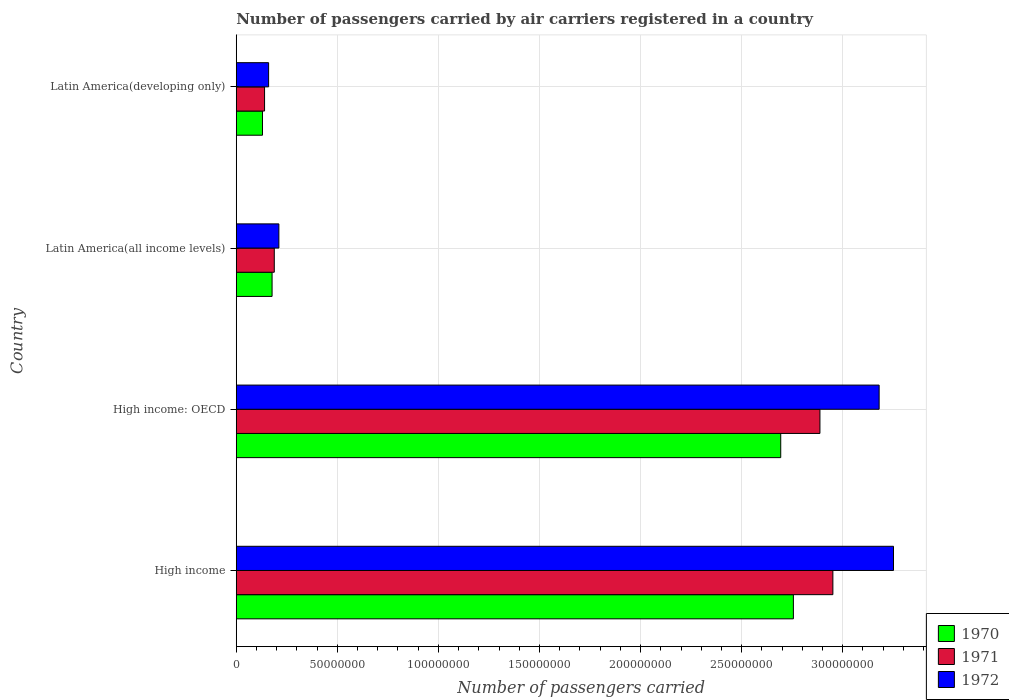How many groups of bars are there?
Provide a succinct answer. 4. Are the number of bars per tick equal to the number of legend labels?
Offer a very short reply. Yes. Are the number of bars on each tick of the Y-axis equal?
Offer a very short reply. Yes. How many bars are there on the 4th tick from the top?
Your response must be concise. 3. How many bars are there on the 2nd tick from the bottom?
Provide a short and direct response. 3. What is the label of the 4th group of bars from the top?
Offer a terse response. High income. What is the number of passengers carried by air carriers in 1970 in Latin America(developing only)?
Offer a terse response. 1.30e+07. Across all countries, what is the maximum number of passengers carried by air carriers in 1970?
Provide a short and direct response. 2.76e+08. Across all countries, what is the minimum number of passengers carried by air carriers in 1970?
Give a very brief answer. 1.30e+07. In which country was the number of passengers carried by air carriers in 1970 maximum?
Provide a short and direct response. High income. In which country was the number of passengers carried by air carriers in 1971 minimum?
Provide a succinct answer. Latin America(developing only). What is the total number of passengers carried by air carriers in 1972 in the graph?
Offer a very short reply. 6.80e+08. What is the difference between the number of passengers carried by air carriers in 1971 in Latin America(all income levels) and that in Latin America(developing only)?
Your response must be concise. 4.81e+06. What is the difference between the number of passengers carried by air carriers in 1972 in High income: OECD and the number of passengers carried by air carriers in 1971 in High income?
Give a very brief answer. 2.29e+07. What is the average number of passengers carried by air carriers in 1970 per country?
Offer a very short reply. 1.44e+08. What is the difference between the number of passengers carried by air carriers in 1971 and number of passengers carried by air carriers in 1970 in Latin America(all income levels)?
Ensure brevity in your answer.  1.09e+06. What is the ratio of the number of passengers carried by air carriers in 1972 in High income: OECD to that in Latin America(developing only)?
Make the answer very short. 19.87. Is the difference between the number of passengers carried by air carriers in 1971 in Latin America(all income levels) and Latin America(developing only) greater than the difference between the number of passengers carried by air carriers in 1970 in Latin America(all income levels) and Latin America(developing only)?
Provide a succinct answer. Yes. What is the difference between the highest and the second highest number of passengers carried by air carriers in 1970?
Offer a very short reply. 6.26e+06. What is the difference between the highest and the lowest number of passengers carried by air carriers in 1970?
Ensure brevity in your answer.  2.63e+08. What does the 3rd bar from the top in Latin America(all income levels) represents?
Your answer should be very brief. 1970. Is it the case that in every country, the sum of the number of passengers carried by air carriers in 1971 and number of passengers carried by air carriers in 1972 is greater than the number of passengers carried by air carriers in 1970?
Keep it short and to the point. Yes. How many bars are there?
Offer a very short reply. 12. How many legend labels are there?
Offer a terse response. 3. How are the legend labels stacked?
Your answer should be very brief. Vertical. What is the title of the graph?
Give a very brief answer. Number of passengers carried by air carriers registered in a country. Does "1995" appear as one of the legend labels in the graph?
Ensure brevity in your answer.  No. What is the label or title of the X-axis?
Offer a very short reply. Number of passengers carried. What is the Number of passengers carried of 1970 in High income?
Give a very brief answer. 2.76e+08. What is the Number of passengers carried in 1971 in High income?
Provide a succinct answer. 2.95e+08. What is the Number of passengers carried in 1972 in High income?
Offer a very short reply. 3.25e+08. What is the Number of passengers carried in 1970 in High income: OECD?
Your answer should be very brief. 2.69e+08. What is the Number of passengers carried of 1971 in High income: OECD?
Provide a short and direct response. 2.89e+08. What is the Number of passengers carried of 1972 in High income: OECD?
Your response must be concise. 3.18e+08. What is the Number of passengers carried of 1970 in Latin America(all income levels)?
Provide a succinct answer. 1.77e+07. What is the Number of passengers carried of 1971 in Latin America(all income levels)?
Make the answer very short. 1.88e+07. What is the Number of passengers carried in 1972 in Latin America(all income levels)?
Offer a very short reply. 2.11e+07. What is the Number of passengers carried in 1970 in Latin America(developing only)?
Make the answer very short. 1.30e+07. What is the Number of passengers carried of 1971 in Latin America(developing only)?
Offer a very short reply. 1.40e+07. What is the Number of passengers carried in 1972 in Latin America(developing only)?
Your response must be concise. 1.60e+07. Across all countries, what is the maximum Number of passengers carried in 1970?
Provide a succinct answer. 2.76e+08. Across all countries, what is the maximum Number of passengers carried in 1971?
Give a very brief answer. 2.95e+08. Across all countries, what is the maximum Number of passengers carried of 1972?
Your answer should be compact. 3.25e+08. Across all countries, what is the minimum Number of passengers carried in 1970?
Provide a short and direct response. 1.30e+07. Across all countries, what is the minimum Number of passengers carried in 1971?
Give a very brief answer. 1.40e+07. Across all countries, what is the minimum Number of passengers carried in 1972?
Provide a succinct answer. 1.60e+07. What is the total Number of passengers carried in 1970 in the graph?
Your answer should be very brief. 5.76e+08. What is the total Number of passengers carried of 1971 in the graph?
Your response must be concise. 6.17e+08. What is the total Number of passengers carried in 1972 in the graph?
Offer a very short reply. 6.80e+08. What is the difference between the Number of passengers carried in 1970 in High income and that in High income: OECD?
Provide a short and direct response. 6.26e+06. What is the difference between the Number of passengers carried in 1971 in High income and that in High income: OECD?
Offer a very short reply. 6.40e+06. What is the difference between the Number of passengers carried of 1972 in High income and that in High income: OECD?
Your answer should be compact. 7.11e+06. What is the difference between the Number of passengers carried of 1970 in High income and that in Latin America(all income levels)?
Provide a short and direct response. 2.58e+08. What is the difference between the Number of passengers carried of 1971 in High income and that in Latin America(all income levels)?
Your answer should be very brief. 2.76e+08. What is the difference between the Number of passengers carried of 1972 in High income and that in Latin America(all income levels)?
Offer a very short reply. 3.04e+08. What is the difference between the Number of passengers carried in 1970 in High income and that in Latin America(developing only)?
Your answer should be very brief. 2.63e+08. What is the difference between the Number of passengers carried of 1971 in High income and that in Latin America(developing only)?
Offer a terse response. 2.81e+08. What is the difference between the Number of passengers carried of 1972 in High income and that in Latin America(developing only)?
Make the answer very short. 3.09e+08. What is the difference between the Number of passengers carried of 1970 in High income: OECD and that in Latin America(all income levels)?
Your answer should be compact. 2.52e+08. What is the difference between the Number of passengers carried in 1971 in High income: OECD and that in Latin America(all income levels)?
Provide a succinct answer. 2.70e+08. What is the difference between the Number of passengers carried in 1972 in High income: OECD and that in Latin America(all income levels)?
Provide a short and direct response. 2.97e+08. What is the difference between the Number of passengers carried of 1970 in High income: OECD and that in Latin America(developing only)?
Give a very brief answer. 2.56e+08. What is the difference between the Number of passengers carried in 1971 in High income: OECD and that in Latin America(developing only)?
Your response must be concise. 2.75e+08. What is the difference between the Number of passengers carried in 1972 in High income: OECD and that in Latin America(developing only)?
Your answer should be very brief. 3.02e+08. What is the difference between the Number of passengers carried in 1970 in Latin America(all income levels) and that in Latin America(developing only)?
Keep it short and to the point. 4.74e+06. What is the difference between the Number of passengers carried of 1971 in Latin America(all income levels) and that in Latin America(developing only)?
Your answer should be compact. 4.81e+06. What is the difference between the Number of passengers carried of 1972 in Latin America(all income levels) and that in Latin America(developing only)?
Make the answer very short. 5.08e+06. What is the difference between the Number of passengers carried in 1970 in High income and the Number of passengers carried in 1971 in High income: OECD?
Provide a short and direct response. -1.31e+07. What is the difference between the Number of passengers carried of 1970 in High income and the Number of passengers carried of 1972 in High income: OECD?
Ensure brevity in your answer.  -4.24e+07. What is the difference between the Number of passengers carried in 1971 in High income and the Number of passengers carried in 1972 in High income: OECD?
Keep it short and to the point. -2.29e+07. What is the difference between the Number of passengers carried of 1970 in High income and the Number of passengers carried of 1971 in Latin America(all income levels)?
Your answer should be compact. 2.57e+08. What is the difference between the Number of passengers carried in 1970 in High income and the Number of passengers carried in 1972 in Latin America(all income levels)?
Your response must be concise. 2.55e+08. What is the difference between the Number of passengers carried in 1971 in High income and the Number of passengers carried in 1972 in Latin America(all income levels)?
Your answer should be very brief. 2.74e+08. What is the difference between the Number of passengers carried in 1970 in High income and the Number of passengers carried in 1971 in Latin America(developing only)?
Offer a terse response. 2.62e+08. What is the difference between the Number of passengers carried of 1970 in High income and the Number of passengers carried of 1972 in Latin America(developing only)?
Provide a short and direct response. 2.60e+08. What is the difference between the Number of passengers carried of 1971 in High income and the Number of passengers carried of 1972 in Latin America(developing only)?
Keep it short and to the point. 2.79e+08. What is the difference between the Number of passengers carried in 1970 in High income: OECD and the Number of passengers carried in 1971 in Latin America(all income levels)?
Ensure brevity in your answer.  2.51e+08. What is the difference between the Number of passengers carried in 1970 in High income: OECD and the Number of passengers carried in 1972 in Latin America(all income levels)?
Offer a terse response. 2.48e+08. What is the difference between the Number of passengers carried of 1971 in High income: OECD and the Number of passengers carried of 1972 in Latin America(all income levels)?
Offer a terse response. 2.68e+08. What is the difference between the Number of passengers carried of 1970 in High income: OECD and the Number of passengers carried of 1971 in Latin America(developing only)?
Ensure brevity in your answer.  2.55e+08. What is the difference between the Number of passengers carried of 1970 in High income: OECD and the Number of passengers carried of 1972 in Latin America(developing only)?
Give a very brief answer. 2.53e+08. What is the difference between the Number of passengers carried in 1971 in High income: OECD and the Number of passengers carried in 1972 in Latin America(developing only)?
Make the answer very short. 2.73e+08. What is the difference between the Number of passengers carried of 1970 in Latin America(all income levels) and the Number of passengers carried of 1971 in Latin America(developing only)?
Offer a very short reply. 3.71e+06. What is the difference between the Number of passengers carried of 1970 in Latin America(all income levels) and the Number of passengers carried of 1972 in Latin America(developing only)?
Your answer should be very brief. 1.71e+06. What is the difference between the Number of passengers carried in 1971 in Latin America(all income levels) and the Number of passengers carried in 1972 in Latin America(developing only)?
Keep it short and to the point. 2.81e+06. What is the average Number of passengers carried of 1970 per country?
Your answer should be very brief. 1.44e+08. What is the average Number of passengers carried of 1971 per country?
Provide a succinct answer. 1.54e+08. What is the average Number of passengers carried in 1972 per country?
Your answer should be compact. 1.70e+08. What is the difference between the Number of passengers carried in 1970 and Number of passengers carried in 1971 in High income?
Ensure brevity in your answer.  -1.95e+07. What is the difference between the Number of passengers carried in 1970 and Number of passengers carried in 1972 in High income?
Give a very brief answer. -4.95e+07. What is the difference between the Number of passengers carried of 1971 and Number of passengers carried of 1972 in High income?
Offer a very short reply. -3.00e+07. What is the difference between the Number of passengers carried in 1970 and Number of passengers carried in 1971 in High income: OECD?
Your response must be concise. -1.94e+07. What is the difference between the Number of passengers carried of 1970 and Number of passengers carried of 1972 in High income: OECD?
Your answer should be compact. -4.87e+07. What is the difference between the Number of passengers carried of 1971 and Number of passengers carried of 1972 in High income: OECD?
Give a very brief answer. -2.93e+07. What is the difference between the Number of passengers carried in 1970 and Number of passengers carried in 1971 in Latin America(all income levels)?
Make the answer very short. -1.09e+06. What is the difference between the Number of passengers carried of 1970 and Number of passengers carried of 1972 in Latin America(all income levels)?
Your response must be concise. -3.36e+06. What is the difference between the Number of passengers carried of 1971 and Number of passengers carried of 1972 in Latin America(all income levels)?
Provide a short and direct response. -2.27e+06. What is the difference between the Number of passengers carried of 1970 and Number of passengers carried of 1971 in Latin America(developing only)?
Give a very brief answer. -1.03e+06. What is the difference between the Number of passengers carried in 1970 and Number of passengers carried in 1972 in Latin America(developing only)?
Offer a terse response. -3.03e+06. What is the difference between the Number of passengers carried in 1971 and Number of passengers carried in 1972 in Latin America(developing only)?
Ensure brevity in your answer.  -2.00e+06. What is the ratio of the Number of passengers carried of 1970 in High income to that in High income: OECD?
Your answer should be compact. 1.02. What is the ratio of the Number of passengers carried in 1971 in High income to that in High income: OECD?
Offer a very short reply. 1.02. What is the ratio of the Number of passengers carried of 1972 in High income to that in High income: OECD?
Your response must be concise. 1.02. What is the ratio of the Number of passengers carried in 1970 in High income to that in Latin America(all income levels)?
Offer a very short reply. 15.55. What is the ratio of the Number of passengers carried in 1971 in High income to that in Latin America(all income levels)?
Offer a terse response. 15.69. What is the ratio of the Number of passengers carried of 1972 in High income to that in Latin America(all income levels)?
Your answer should be very brief. 15.42. What is the ratio of the Number of passengers carried of 1970 in High income to that in Latin America(developing only)?
Offer a terse response. 21.24. What is the ratio of the Number of passengers carried of 1971 in High income to that in Latin America(developing only)?
Your answer should be compact. 21.07. What is the ratio of the Number of passengers carried in 1972 in High income to that in Latin America(developing only)?
Ensure brevity in your answer.  20.31. What is the ratio of the Number of passengers carried of 1970 in High income: OECD to that in Latin America(all income levels)?
Provide a short and direct response. 15.2. What is the ratio of the Number of passengers carried in 1971 in High income: OECD to that in Latin America(all income levels)?
Provide a succinct answer. 15.35. What is the ratio of the Number of passengers carried in 1972 in High income: OECD to that in Latin America(all income levels)?
Your response must be concise. 15.09. What is the ratio of the Number of passengers carried of 1970 in High income: OECD to that in Latin America(developing only)?
Your response must be concise. 20.75. What is the ratio of the Number of passengers carried in 1971 in High income: OECD to that in Latin America(developing only)?
Make the answer very short. 20.62. What is the ratio of the Number of passengers carried of 1972 in High income: OECD to that in Latin America(developing only)?
Give a very brief answer. 19.87. What is the ratio of the Number of passengers carried of 1970 in Latin America(all income levels) to that in Latin America(developing only)?
Provide a short and direct response. 1.37. What is the ratio of the Number of passengers carried in 1971 in Latin America(all income levels) to that in Latin America(developing only)?
Your response must be concise. 1.34. What is the ratio of the Number of passengers carried in 1972 in Latin America(all income levels) to that in Latin America(developing only)?
Your answer should be very brief. 1.32. What is the difference between the highest and the second highest Number of passengers carried of 1970?
Your response must be concise. 6.26e+06. What is the difference between the highest and the second highest Number of passengers carried in 1971?
Provide a succinct answer. 6.40e+06. What is the difference between the highest and the second highest Number of passengers carried in 1972?
Give a very brief answer. 7.11e+06. What is the difference between the highest and the lowest Number of passengers carried in 1970?
Offer a terse response. 2.63e+08. What is the difference between the highest and the lowest Number of passengers carried in 1971?
Your answer should be compact. 2.81e+08. What is the difference between the highest and the lowest Number of passengers carried of 1972?
Provide a short and direct response. 3.09e+08. 